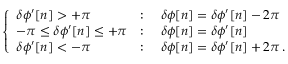<formula> <loc_0><loc_0><loc_500><loc_500>\left \{ \begin{array} { l l } { \delta \phi ^ { \prime } [ n ] > + \pi } & { \colon \quad \delta \phi [ n ] = \delta \phi ^ { \prime } [ n ] - 2 \pi } \\ { - \pi \leq \delta \phi ^ { \prime } [ n ] \leq + \pi } & { \colon \quad \delta \phi [ n ] = \delta \phi ^ { \prime } [ n ] } \\ { \delta \phi ^ { \prime } [ n ] < - \pi } & { \colon \quad \delta \phi [ n ] = \delta \phi ^ { \prime } [ n ] + 2 \pi \, . } \end{array}</formula> 